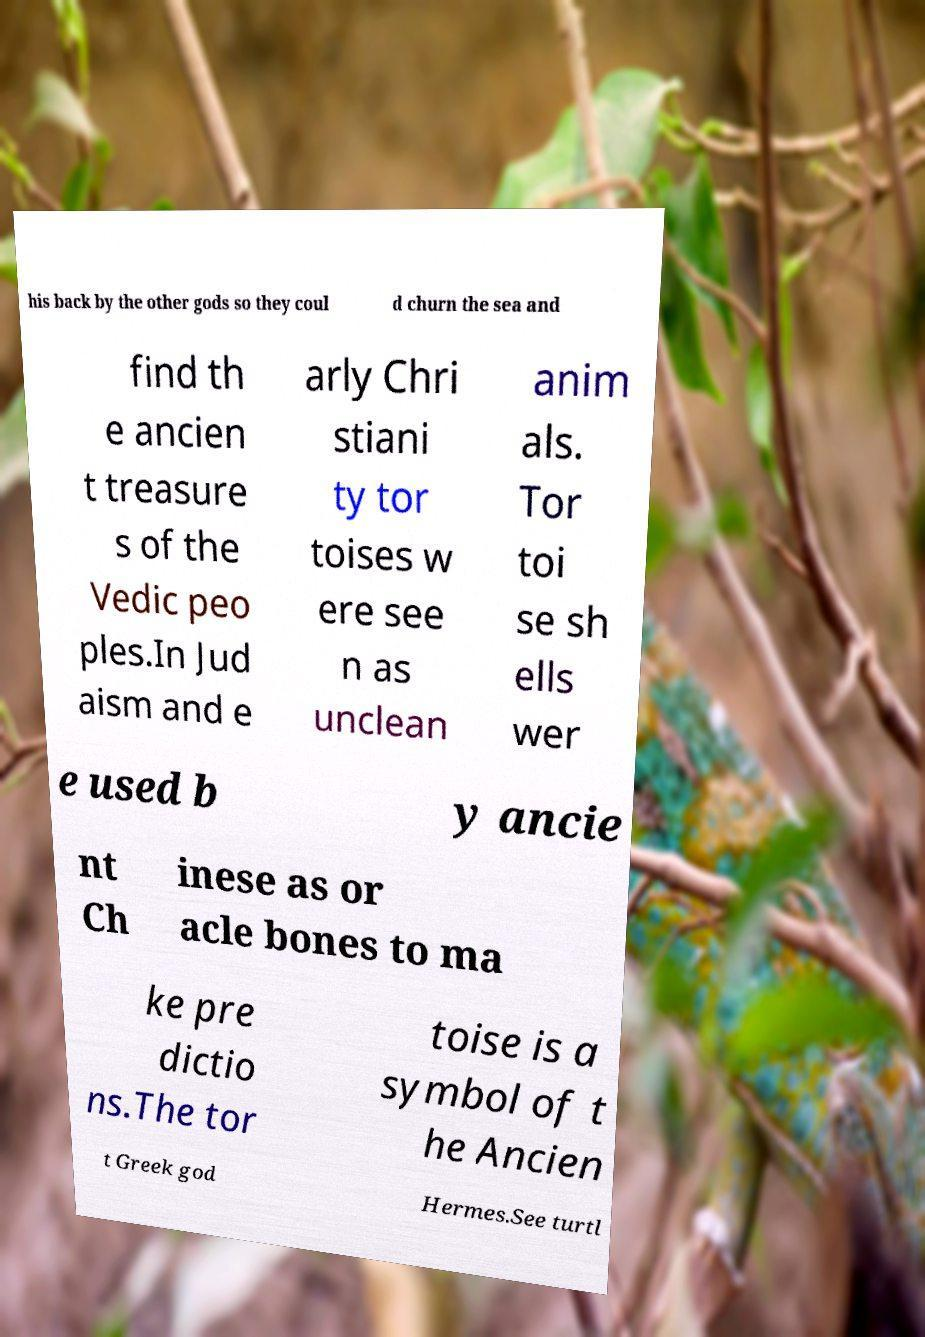Could you assist in decoding the text presented in this image and type it out clearly? his back by the other gods so they coul d churn the sea and find th e ancien t treasure s of the Vedic peo ples.In Jud aism and e arly Chri stiani ty tor toises w ere see n as unclean anim als. Tor toi se sh ells wer e used b y ancie nt Ch inese as or acle bones to ma ke pre dictio ns.The tor toise is a symbol of t he Ancien t Greek god Hermes.See turtl 